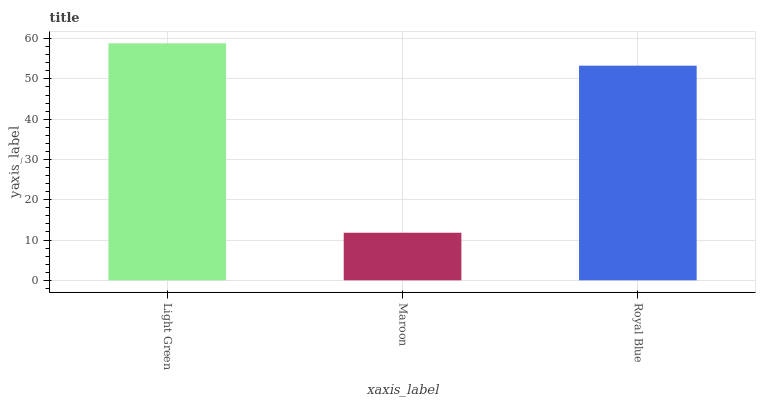Is Maroon the minimum?
Answer yes or no. Yes. Is Light Green the maximum?
Answer yes or no. Yes. Is Royal Blue the minimum?
Answer yes or no. No. Is Royal Blue the maximum?
Answer yes or no. No. Is Royal Blue greater than Maroon?
Answer yes or no. Yes. Is Maroon less than Royal Blue?
Answer yes or no. Yes. Is Maroon greater than Royal Blue?
Answer yes or no. No. Is Royal Blue less than Maroon?
Answer yes or no. No. Is Royal Blue the high median?
Answer yes or no. Yes. Is Royal Blue the low median?
Answer yes or no. Yes. Is Light Green the high median?
Answer yes or no. No. Is Light Green the low median?
Answer yes or no. No. 